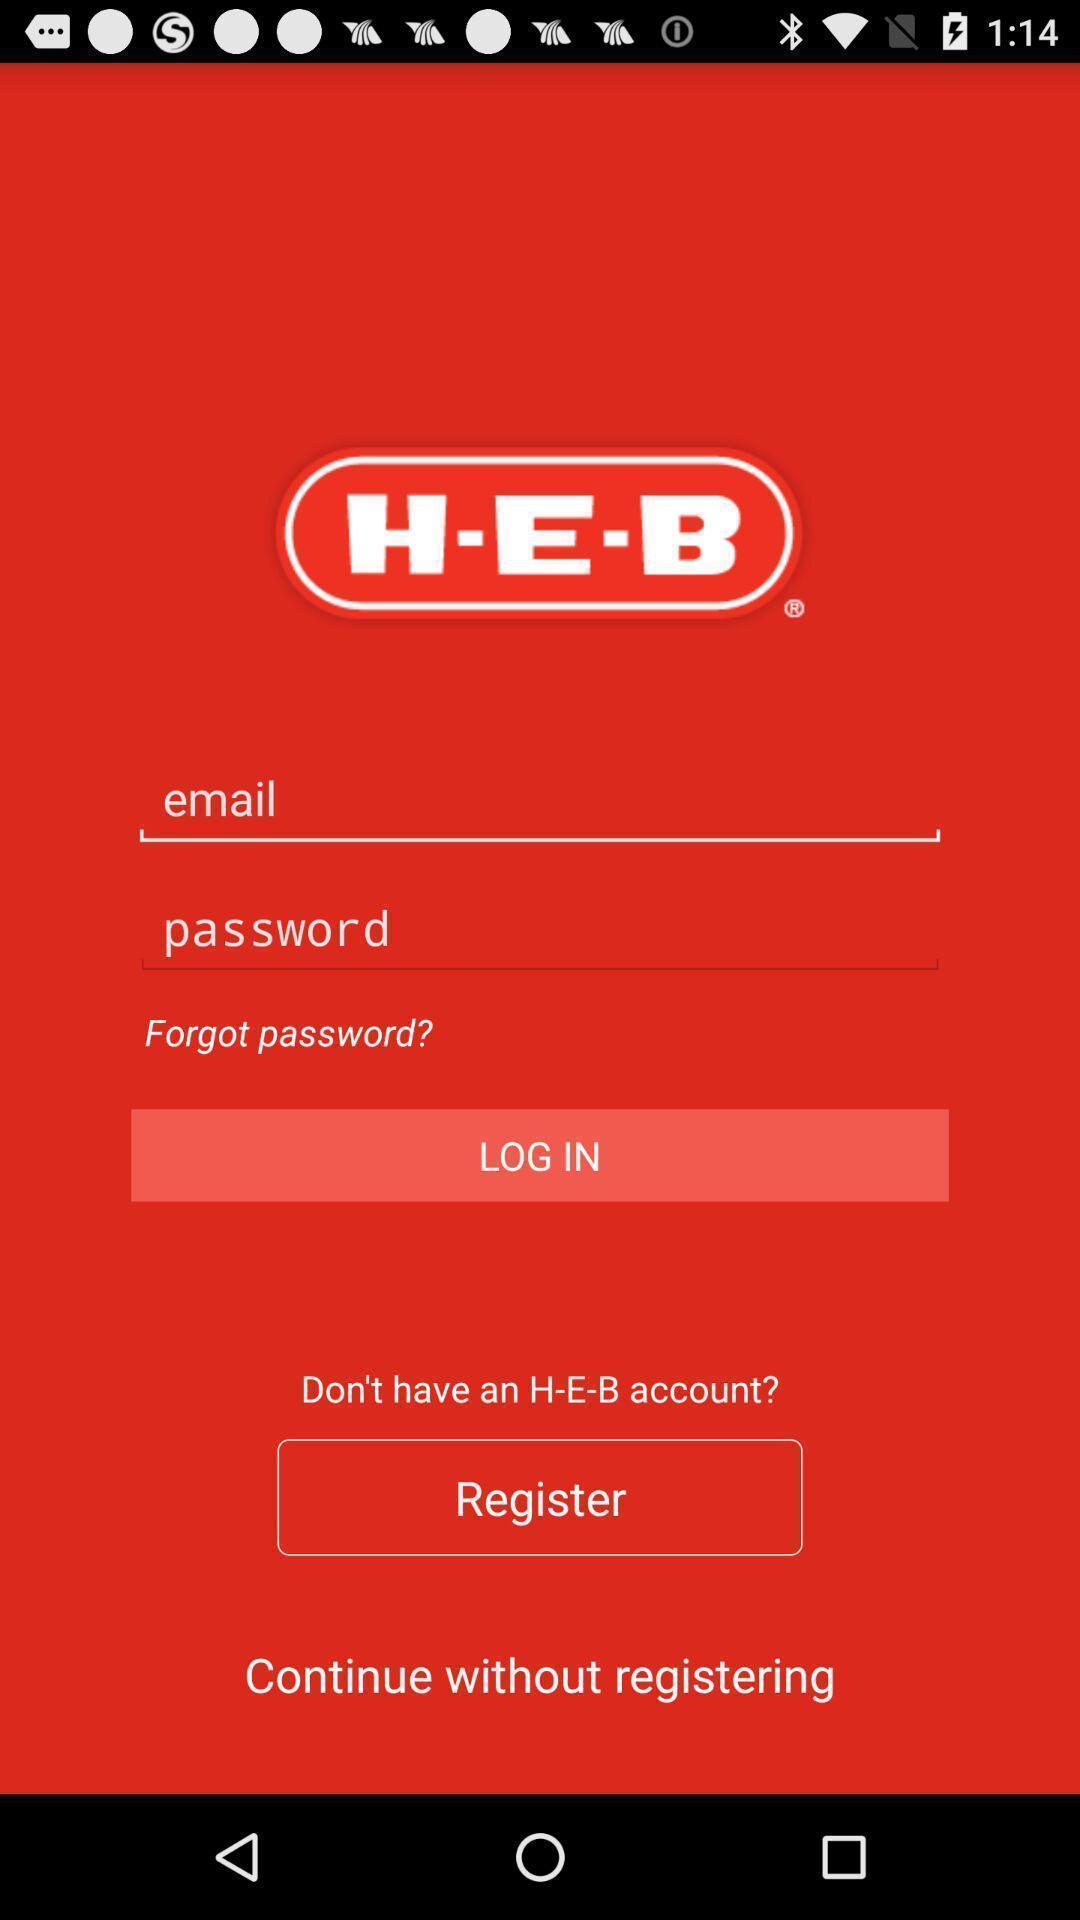What details can you identify in this image? Login page. 